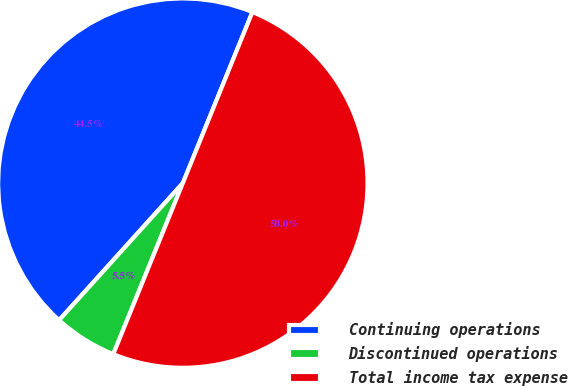<chart> <loc_0><loc_0><loc_500><loc_500><pie_chart><fcel>Continuing operations<fcel>Discontinued operations<fcel>Total income tax expense<nl><fcel>44.46%<fcel>5.54%<fcel>50.0%<nl></chart> 